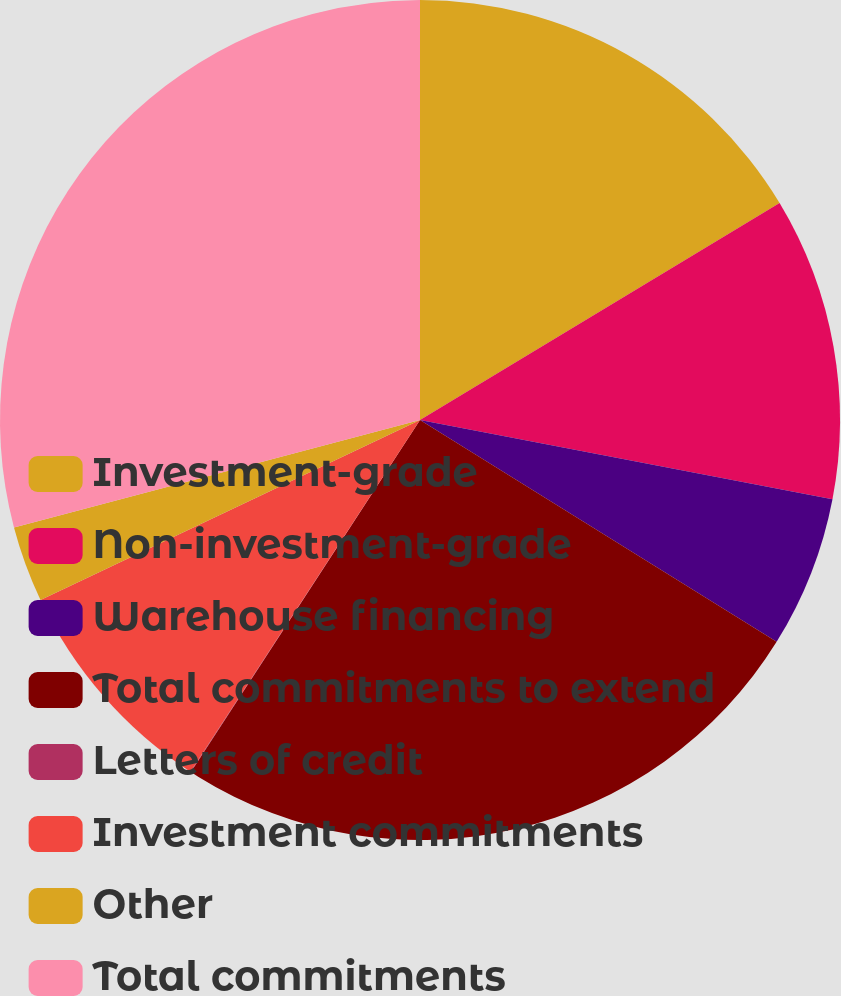<chart> <loc_0><loc_0><loc_500><loc_500><pie_chart><fcel>Investment-grade<fcel>Non-investment-grade<fcel>Warehouse financing<fcel>Total commitments to extend<fcel>Letters of credit<fcel>Investment commitments<fcel>Other<fcel>Total commitments<nl><fcel>16.36%<fcel>11.66%<fcel>5.84%<fcel>25.33%<fcel>0.02%<fcel>8.75%<fcel>2.93%<fcel>29.12%<nl></chart> 